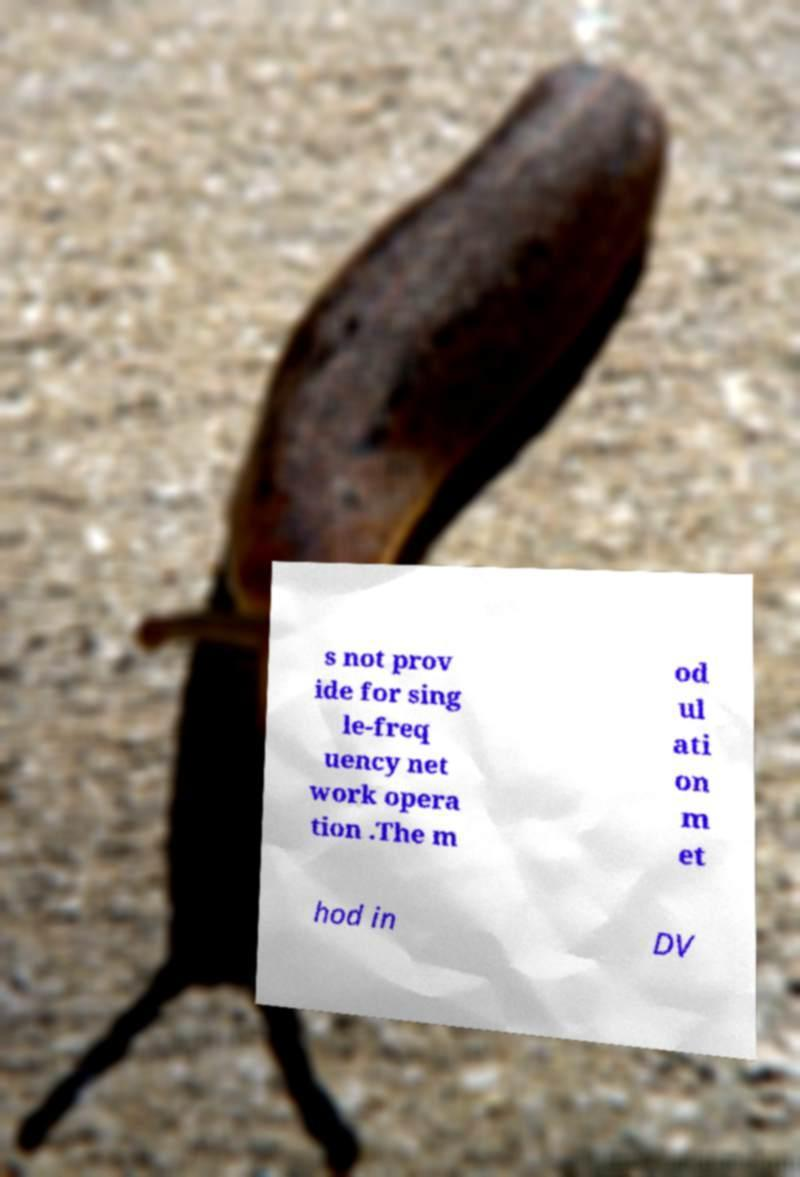There's text embedded in this image that I need extracted. Can you transcribe it verbatim? s not prov ide for sing le-freq uency net work opera tion .The m od ul ati on m et hod in DV 